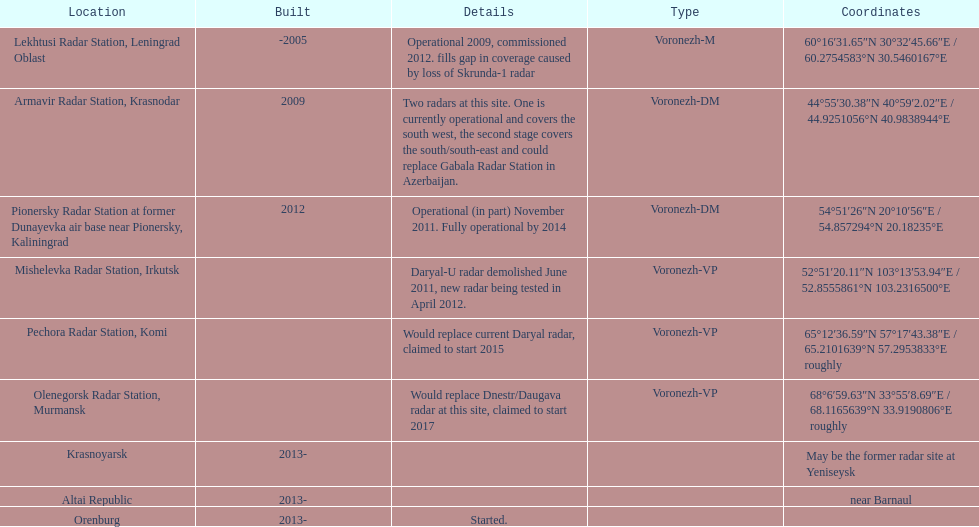How long did it take the pionersky radar station to go from partially operational to fully operational? 3 years. 